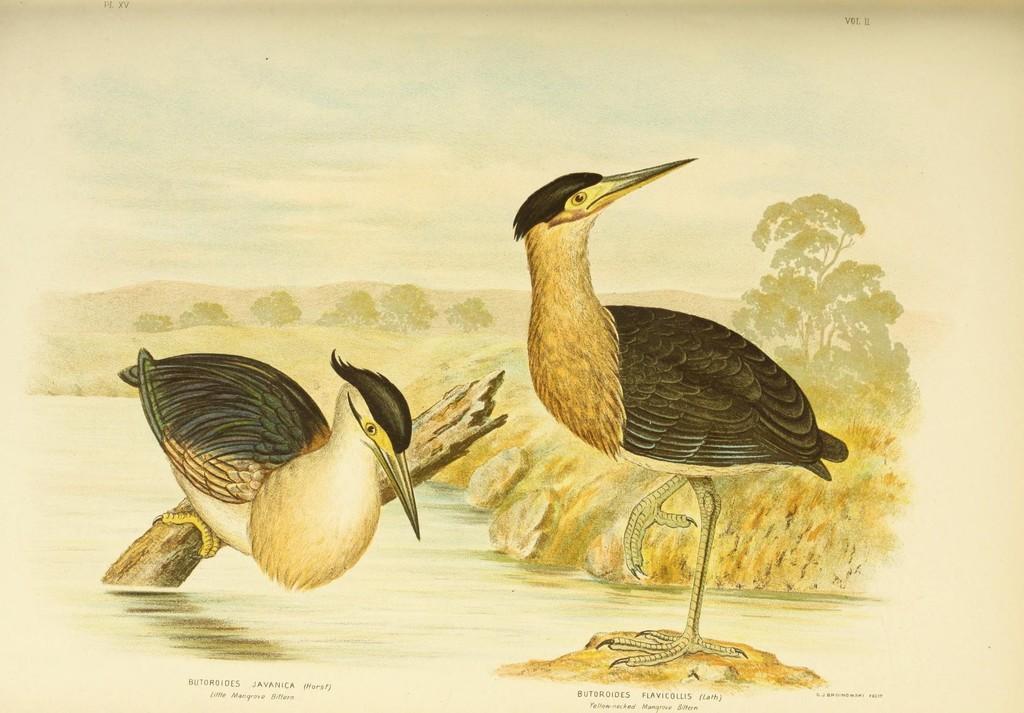Could you give a brief overview of what you see in this image? This is an image of the painting where we can see there are birds standing on the wooden pieces on water beside that there is a mud road, trees and mountains. 